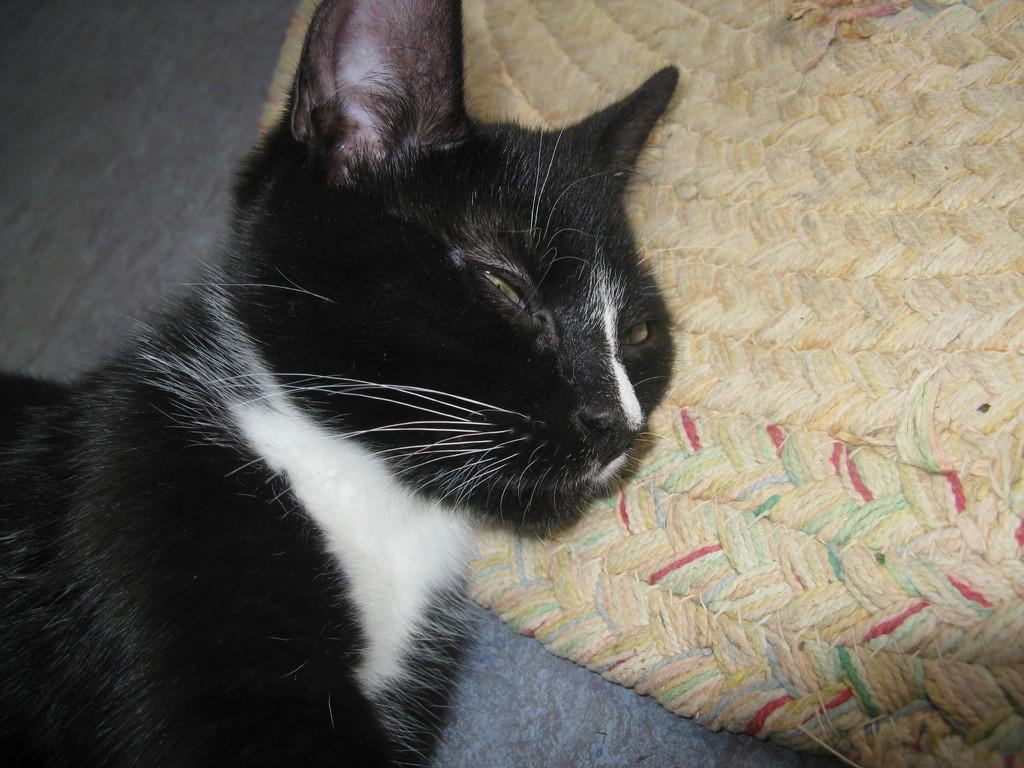What type of animal is in the image? There is a cat in the image. Where is the cat located? The cat is lying on a bed. What type of gun is the cat holding in the image? There is no gun present in the image; it only features a cat lying on a bed. 